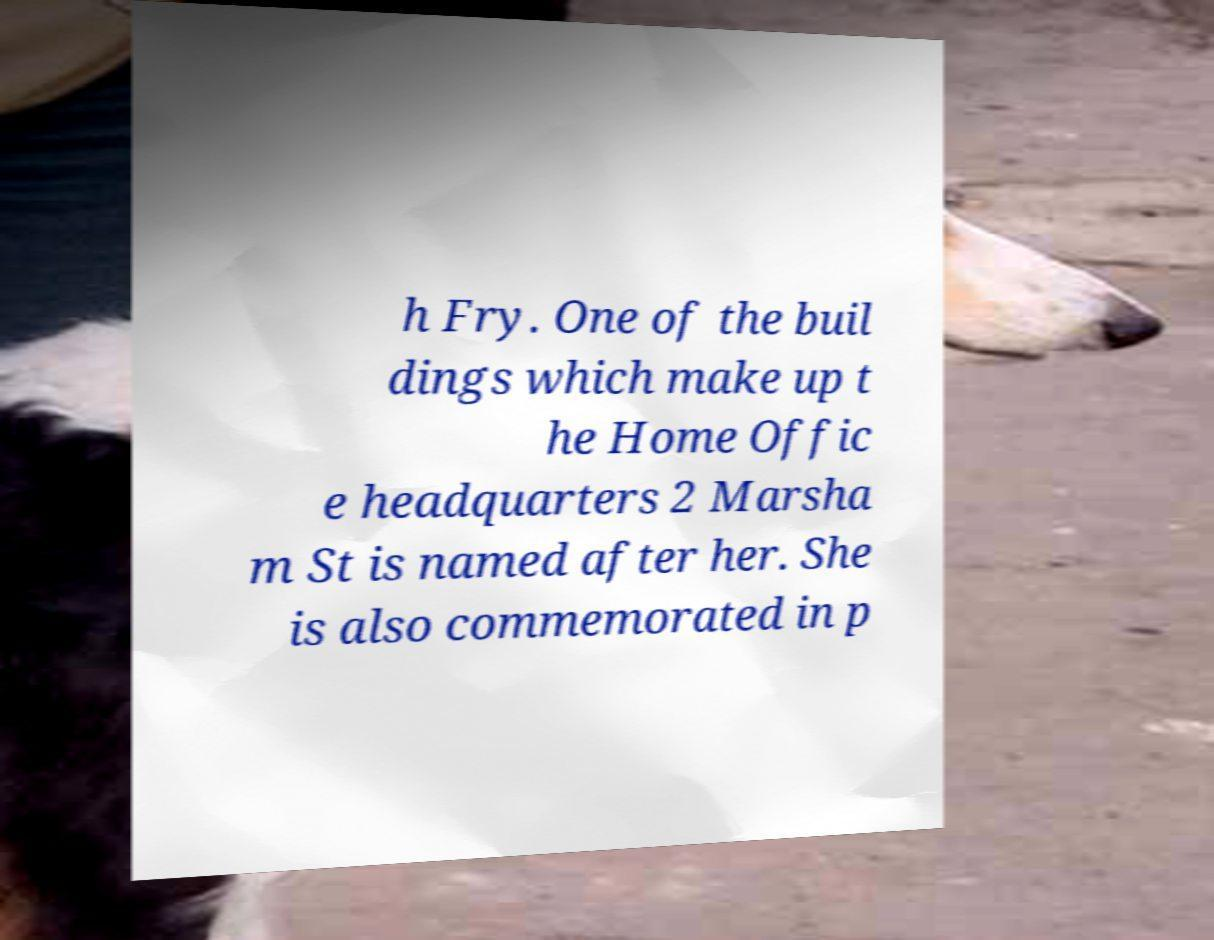I need the written content from this picture converted into text. Can you do that? h Fry. One of the buil dings which make up t he Home Offic e headquarters 2 Marsha m St is named after her. She is also commemorated in p 